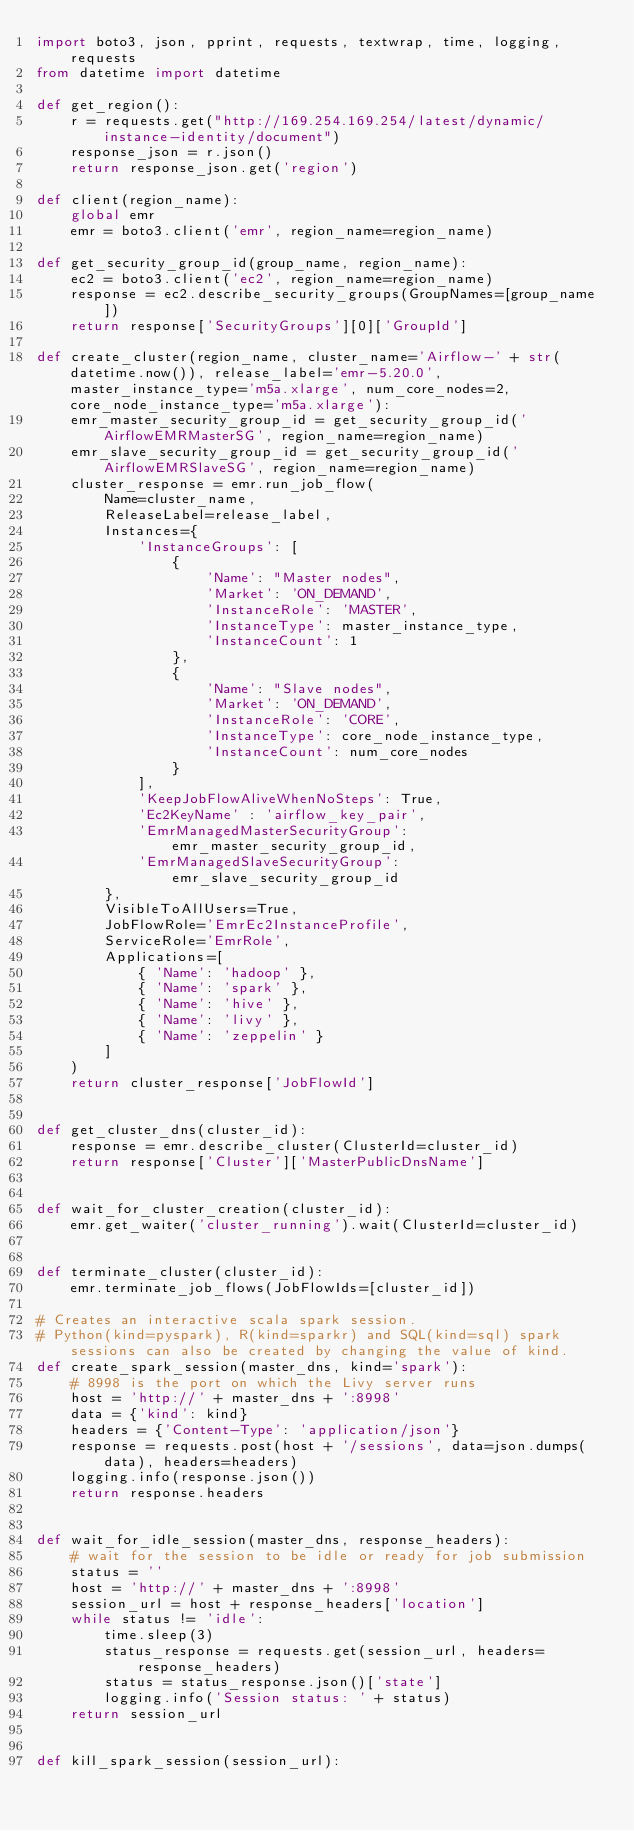<code> <loc_0><loc_0><loc_500><loc_500><_Python_>import boto3, json, pprint, requests, textwrap, time, logging, requests
from datetime import datetime

def get_region():
    r = requests.get("http://169.254.169.254/latest/dynamic/instance-identity/document")
    response_json = r.json()
    return response_json.get('region')

def client(region_name):
    global emr
    emr = boto3.client('emr', region_name=region_name)

def get_security_group_id(group_name, region_name):
    ec2 = boto3.client('ec2', region_name=region_name)
    response = ec2.describe_security_groups(GroupNames=[group_name])
    return response['SecurityGroups'][0]['GroupId']

def create_cluster(region_name, cluster_name='Airflow-' + str(datetime.now()), release_label='emr-5.20.0',master_instance_type='m5a.xlarge', num_core_nodes=2, core_node_instance_type='m5a.xlarge'):
    emr_master_security_group_id = get_security_group_id('AirflowEMRMasterSG', region_name=region_name)
    emr_slave_security_group_id = get_security_group_id('AirflowEMRSlaveSG', region_name=region_name)
    cluster_response = emr.run_job_flow(
        Name=cluster_name,
        ReleaseLabel=release_label,
        Instances={
            'InstanceGroups': [
                {
                    'Name': "Master nodes",
                    'Market': 'ON_DEMAND',
                    'InstanceRole': 'MASTER',
                    'InstanceType': master_instance_type,
                    'InstanceCount': 1
                },
                {
                    'Name': "Slave nodes",
                    'Market': 'ON_DEMAND',
                    'InstanceRole': 'CORE',
                    'InstanceType': core_node_instance_type,
                    'InstanceCount': num_core_nodes
                }
            ],
            'KeepJobFlowAliveWhenNoSteps': True,
            'Ec2KeyName' : 'airflow_key_pair',
            'EmrManagedMasterSecurityGroup': emr_master_security_group_id,
            'EmrManagedSlaveSecurityGroup': emr_slave_security_group_id
        },
        VisibleToAllUsers=True,
        JobFlowRole='EmrEc2InstanceProfile',
        ServiceRole='EmrRole',
        Applications=[
            { 'Name': 'hadoop' },
            { 'Name': 'spark' },
            { 'Name': 'hive' },
            { 'Name': 'livy' },
            { 'Name': 'zeppelin' }
        ]
    )
    return cluster_response['JobFlowId']


def get_cluster_dns(cluster_id):
    response = emr.describe_cluster(ClusterId=cluster_id)
    return response['Cluster']['MasterPublicDnsName']


def wait_for_cluster_creation(cluster_id):
    emr.get_waiter('cluster_running').wait(ClusterId=cluster_id)


def terminate_cluster(cluster_id):
    emr.terminate_job_flows(JobFlowIds=[cluster_id])

# Creates an interactive scala spark session.
# Python(kind=pyspark), R(kind=sparkr) and SQL(kind=sql) spark sessions can also be created by changing the value of kind.
def create_spark_session(master_dns, kind='spark'):
    # 8998 is the port on which the Livy server runs
    host = 'http://' + master_dns + ':8998'
    data = {'kind': kind}
    headers = {'Content-Type': 'application/json'}
    response = requests.post(host + '/sessions', data=json.dumps(data), headers=headers)
    logging.info(response.json())
    return response.headers


def wait_for_idle_session(master_dns, response_headers):
    # wait for the session to be idle or ready for job submission
    status = ''
    host = 'http://' + master_dns + ':8998'
    session_url = host + response_headers['location']
    while status != 'idle':
        time.sleep(3)
        status_response = requests.get(session_url, headers=response_headers)
        status = status_response.json()['state']
        logging.info('Session status: ' + status)
    return session_url


def kill_spark_session(session_url):</code> 